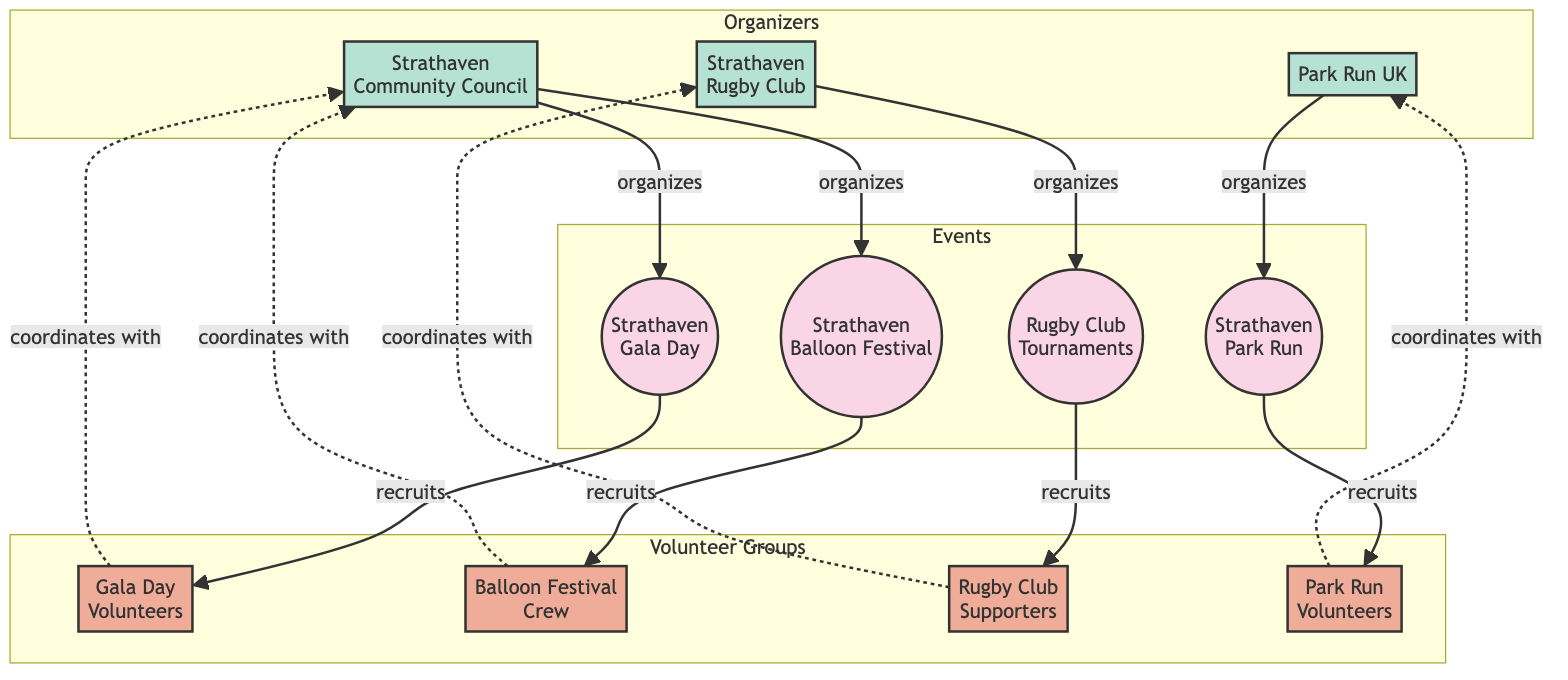What's the total number of events in the diagram? The diagram lists four events: Strathaven Gala Day, Strathaven Balloon Festival, Rugby Club Tournaments, and Strathaven Park Run. Counting these, we find there are a total of four events.
Answer: 4 Which volunteer group is associated with the Strathaven Gala Day? The edge labeled "recruits" shows that the Strathaven Gala Day is connected to the Gala Day Volunteers, indicating this group is specifically associated with the event.
Answer: Gala Day Volunteers How many organizers are coordinating the sports events? The diagram identifies three organizers: Strathaven Community Council, Strathaven Rugby Club, and Park Run UK. There are no additional organizers mentioned. Therefore, the total number of organizers is three.
Answer: 3 What type of relationships exist between volunteer groups and their corresponding events? Each volunteer group has a "recruits" relationship with its respective event, meaning that each event is actively recruiting its associated volunteer team for assistance.
Answer: recruits Which organizer manages the Rugby Club Tournaments? The edge labeled "organizes" directly connects the Rugby Club Tournaments to the Strathaven Rugby Club, showing that this organization is responsible for managing the event.
Answer: Strathaven Rugby Club Which volunteer group coordinates with the Park Run UK? Upon examining the diagram, we see that the Park Run Volunteers have a "coordinates with" relationship with Park Run UK, indicating that this is the volunteer group coordinated by this organizer.
Answer: Park Run Volunteers How many unique edges are present in the diagram? The diagram contains unique edges representing relationships between nodes; there are a total of eight edges established between events, volunteer groups, and organizers.
Answer: 8 Which event is organized by the Strathaven Community Council? The edges labeled "organizes" show that Strathaven Community Council manages both the Strathaven Gala Day and the Strathaven Balloon Festival, so it organizes both events.
Answer: Strathaven Gala Day and Strathaven Balloon Festival What type of node represents the volunteer teams in the diagram? The diagram uses the label "volunteerGroup" to classify volunteer teams, denoting that these nodes specifically represent the volunteer teams involved in the events.
Answer: volunteerGroup 